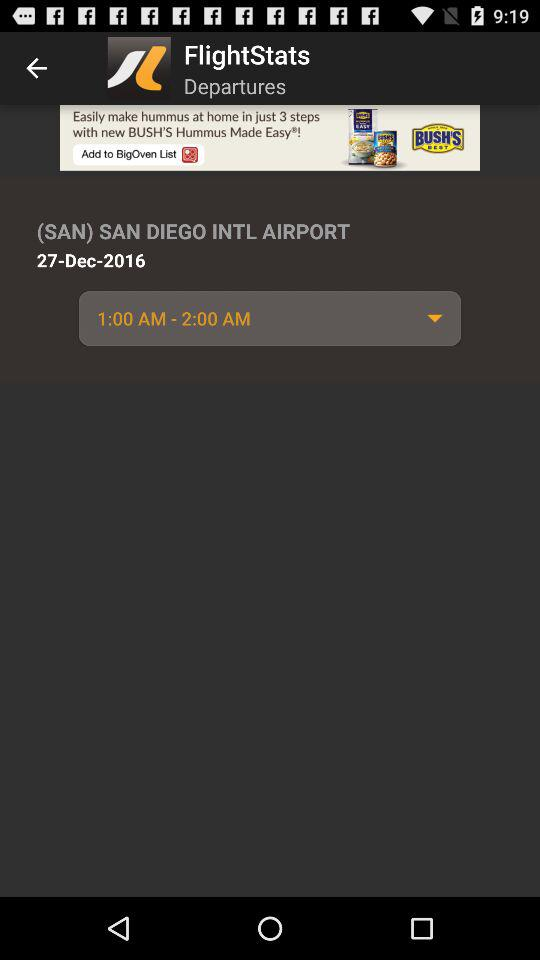What is the time range? The time range is 1:00 AM-2:00 AM. 